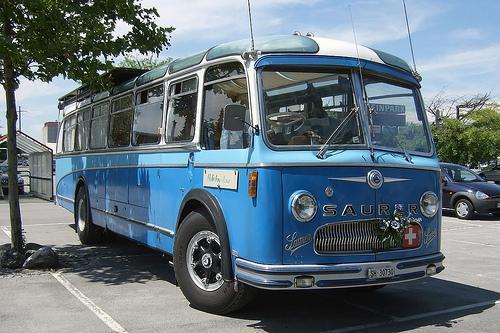How many busses are there?
Give a very brief answer. 1. 